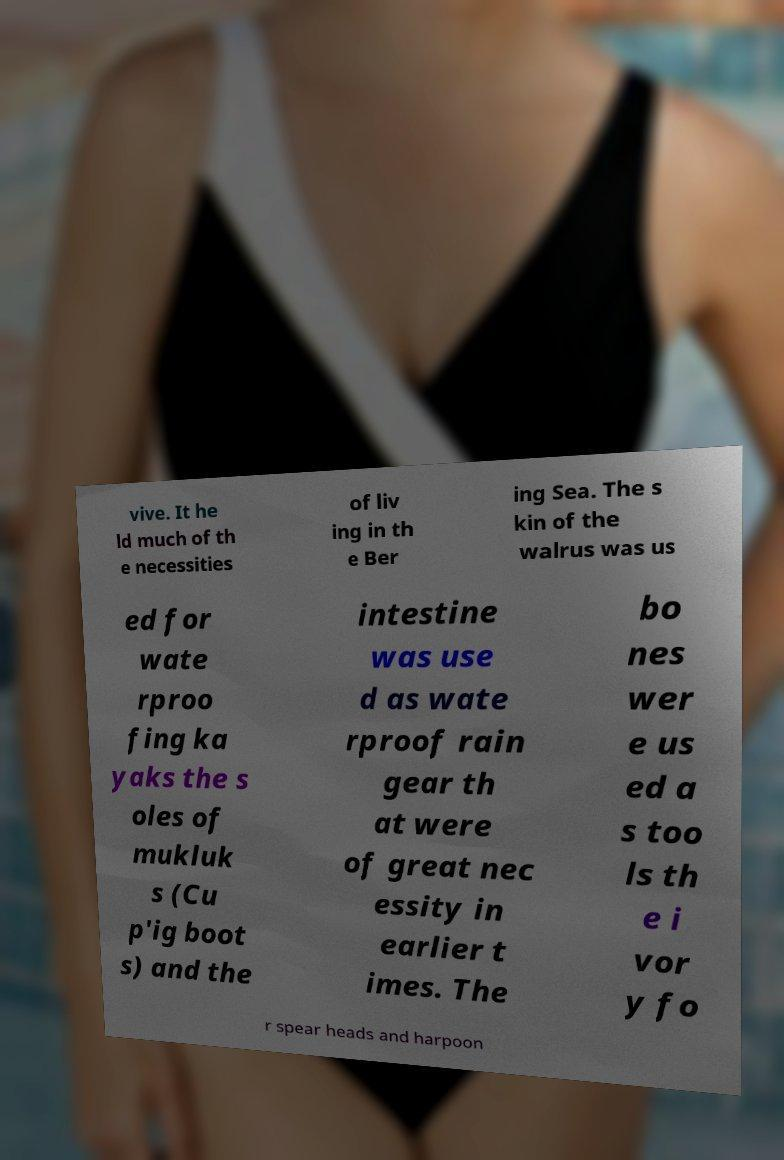Could you assist in decoding the text presented in this image and type it out clearly? vive. It he ld much of th e necessities of liv ing in th e Ber ing Sea. The s kin of the walrus was us ed for wate rproo fing ka yaks the s oles of mukluk s (Cu p'ig boot s) and the intestine was use d as wate rproof rain gear th at were of great nec essity in earlier t imes. The bo nes wer e us ed a s too ls th e i vor y fo r spear heads and harpoon 